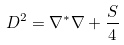<formula> <loc_0><loc_0><loc_500><loc_500>D ^ { 2 } = \nabla ^ { \ast } \nabla + \frac { S } { 4 }</formula> 